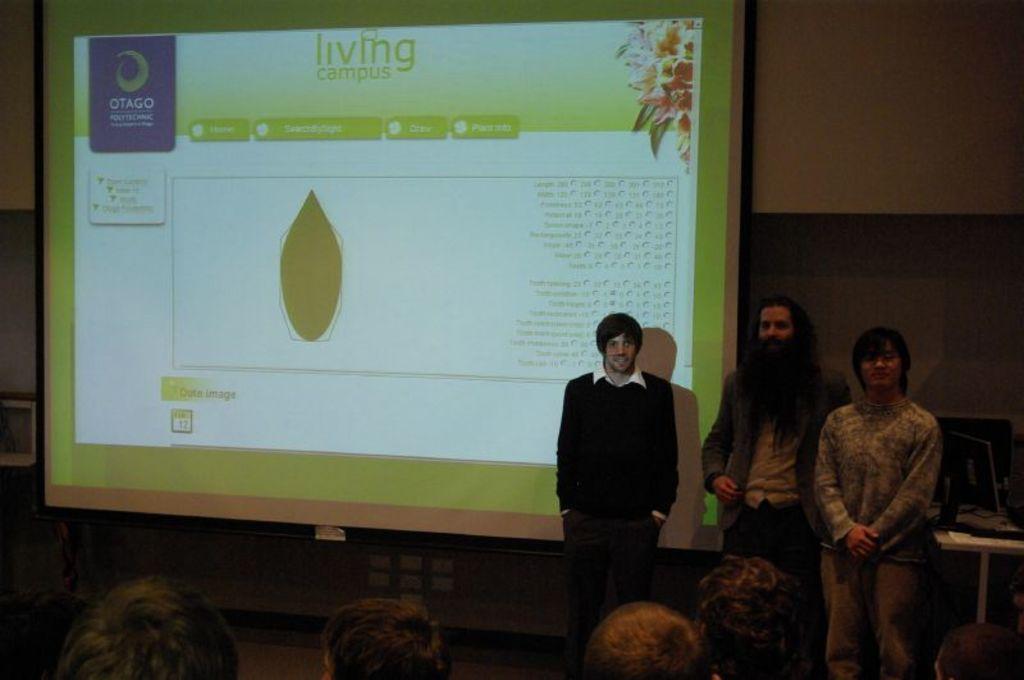Please provide a concise description of this image. In the foreground of the picture we can see heads of the people. In the center of the picture there are people standing and there are desk and other objects. In the background there is a projector screen and wall. 